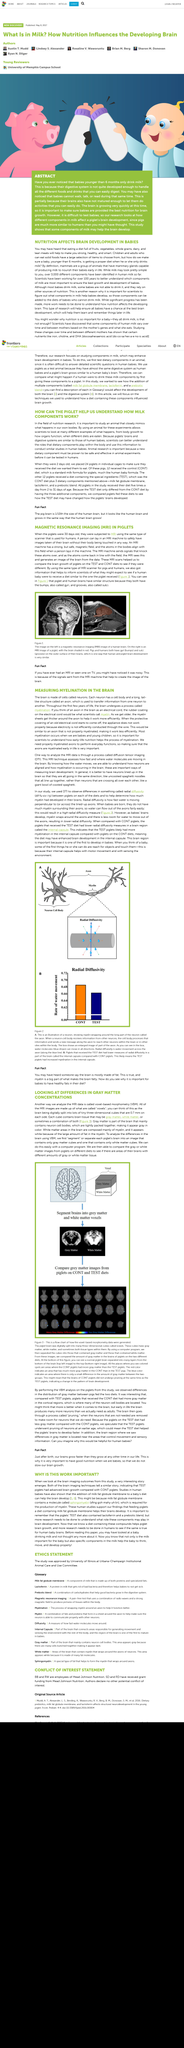Outline some significant characteristics in this image. Researchers conduct experiments on piglets to understand the effects of milk on brain development in animals. Nutrition research studies the effects of diet on human health by examining the results in animals to determine potential outcomes in humans. Pigs, with their similarities to human babies in terms of brain and digestive system, can help us understand how milk works and its benefits for human babies. Animal research is essential because the safety and efficacy of a new dietary component must be demonstrated in animals before it can be tested on humans. Babies' digestive systems are not developed enough to handle the same variety of foods and drinks that adults can easily digest, as demonstrated by their inability to digest certain foods. 